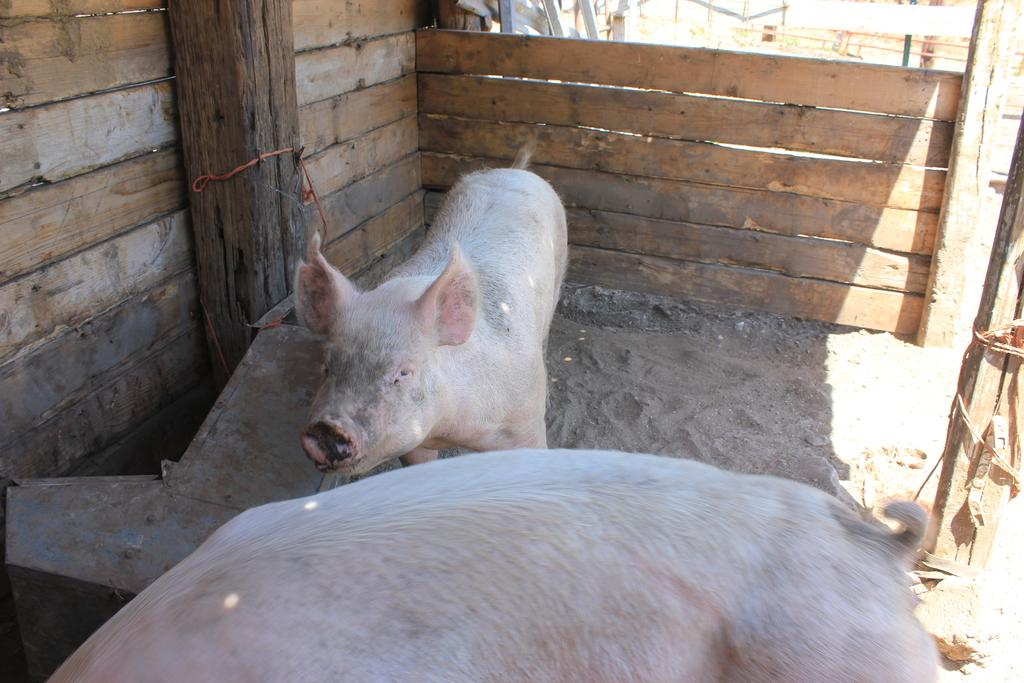How many pigs are in the image? There are two pigs in the image. What type of material is used for the walls in the image? The walls in the image are made of wood. What are the poles used for in the image? The purpose of the poles in the image is not specified, but they could be used for support or as part of a structure. What object can be seen in the image that might be used for storage or containment? There is a box in the image that could be used for storage or containment. What can be seen on the right side of the image that might be used for tying or securing? There are ropes on the right side of the image that could be used for tying or securing. What type of pie is being served to the pigs in the image? There is no pie present in the image; it features two pigs and various objects such as wooden walls, poles, a box, and ropes. 